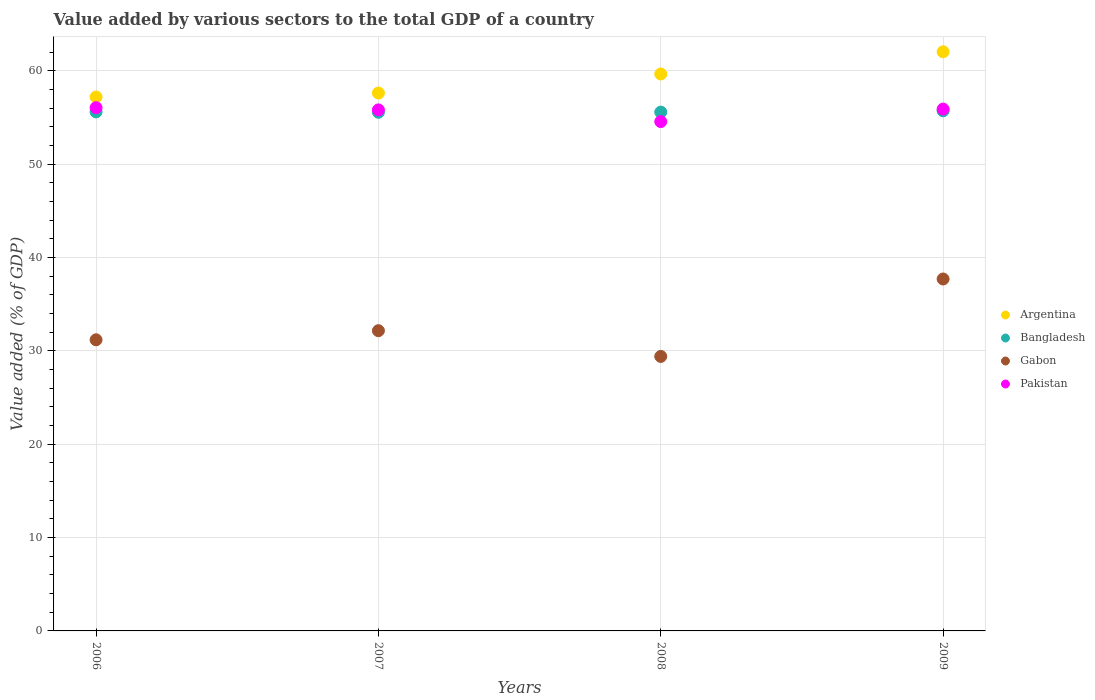Is the number of dotlines equal to the number of legend labels?
Offer a terse response. Yes. What is the value added by various sectors to the total GDP in Pakistan in 2009?
Ensure brevity in your answer.  55.89. Across all years, what is the maximum value added by various sectors to the total GDP in Argentina?
Offer a terse response. 62.03. Across all years, what is the minimum value added by various sectors to the total GDP in Pakistan?
Your answer should be compact. 54.56. In which year was the value added by various sectors to the total GDP in Argentina maximum?
Offer a terse response. 2009. What is the total value added by various sectors to the total GDP in Gabon in the graph?
Offer a very short reply. 130.44. What is the difference between the value added by various sectors to the total GDP in Bangladesh in 2006 and that in 2008?
Keep it short and to the point. 0.03. What is the difference between the value added by various sectors to the total GDP in Gabon in 2006 and the value added by various sectors to the total GDP in Pakistan in 2007?
Offer a terse response. -24.63. What is the average value added by various sectors to the total GDP in Bangladesh per year?
Keep it short and to the point. 55.61. In the year 2009, what is the difference between the value added by various sectors to the total GDP in Bangladesh and value added by various sectors to the total GDP in Argentina?
Offer a terse response. -6.32. What is the ratio of the value added by various sectors to the total GDP in Bangladesh in 2008 to that in 2009?
Make the answer very short. 1. Is the value added by various sectors to the total GDP in Argentina in 2007 less than that in 2009?
Ensure brevity in your answer.  Yes. What is the difference between the highest and the second highest value added by various sectors to the total GDP in Argentina?
Keep it short and to the point. 2.38. What is the difference between the highest and the lowest value added by various sectors to the total GDP in Gabon?
Provide a short and direct response. 8.29. Is the sum of the value added by various sectors to the total GDP in Bangladesh in 2007 and 2009 greater than the maximum value added by various sectors to the total GDP in Argentina across all years?
Keep it short and to the point. Yes. Is the value added by various sectors to the total GDP in Bangladesh strictly greater than the value added by various sectors to the total GDP in Pakistan over the years?
Your answer should be compact. No. How many dotlines are there?
Your answer should be compact. 4. Does the graph contain any zero values?
Offer a terse response. No. Where does the legend appear in the graph?
Ensure brevity in your answer.  Center right. How many legend labels are there?
Provide a succinct answer. 4. What is the title of the graph?
Provide a short and direct response. Value added by various sectors to the total GDP of a country. Does "Brunei Darussalam" appear as one of the legend labels in the graph?
Your response must be concise. No. What is the label or title of the Y-axis?
Make the answer very short. Value added (% of GDP). What is the Value added (% of GDP) of Argentina in 2006?
Offer a very short reply. 57.19. What is the Value added (% of GDP) of Bangladesh in 2006?
Your answer should be compact. 55.59. What is the Value added (% of GDP) of Gabon in 2006?
Offer a very short reply. 31.18. What is the Value added (% of GDP) of Pakistan in 2006?
Your answer should be very brief. 56.04. What is the Value added (% of GDP) in Argentina in 2007?
Your response must be concise. 57.61. What is the Value added (% of GDP) in Bangladesh in 2007?
Offer a terse response. 55.56. What is the Value added (% of GDP) of Gabon in 2007?
Offer a terse response. 32.16. What is the Value added (% of GDP) in Pakistan in 2007?
Offer a very short reply. 55.81. What is the Value added (% of GDP) in Argentina in 2008?
Your answer should be very brief. 59.65. What is the Value added (% of GDP) in Bangladesh in 2008?
Make the answer very short. 55.57. What is the Value added (% of GDP) of Gabon in 2008?
Ensure brevity in your answer.  29.4. What is the Value added (% of GDP) in Pakistan in 2008?
Give a very brief answer. 54.56. What is the Value added (% of GDP) of Argentina in 2009?
Give a very brief answer. 62.03. What is the Value added (% of GDP) in Bangladesh in 2009?
Offer a terse response. 55.71. What is the Value added (% of GDP) of Gabon in 2009?
Give a very brief answer. 37.7. What is the Value added (% of GDP) of Pakistan in 2009?
Keep it short and to the point. 55.89. Across all years, what is the maximum Value added (% of GDP) in Argentina?
Offer a very short reply. 62.03. Across all years, what is the maximum Value added (% of GDP) of Bangladesh?
Offer a very short reply. 55.71. Across all years, what is the maximum Value added (% of GDP) in Gabon?
Ensure brevity in your answer.  37.7. Across all years, what is the maximum Value added (% of GDP) of Pakistan?
Provide a succinct answer. 56.04. Across all years, what is the minimum Value added (% of GDP) of Argentina?
Make the answer very short. 57.19. Across all years, what is the minimum Value added (% of GDP) of Bangladesh?
Give a very brief answer. 55.56. Across all years, what is the minimum Value added (% of GDP) of Gabon?
Offer a terse response. 29.4. Across all years, what is the minimum Value added (% of GDP) of Pakistan?
Keep it short and to the point. 54.56. What is the total Value added (% of GDP) of Argentina in the graph?
Provide a short and direct response. 236.49. What is the total Value added (% of GDP) of Bangladesh in the graph?
Provide a short and direct response. 222.42. What is the total Value added (% of GDP) in Gabon in the graph?
Ensure brevity in your answer.  130.44. What is the total Value added (% of GDP) in Pakistan in the graph?
Your response must be concise. 222.3. What is the difference between the Value added (% of GDP) of Argentina in 2006 and that in 2007?
Ensure brevity in your answer.  -0.42. What is the difference between the Value added (% of GDP) in Bangladesh in 2006 and that in 2007?
Your answer should be compact. 0.04. What is the difference between the Value added (% of GDP) in Gabon in 2006 and that in 2007?
Provide a short and direct response. -0.98. What is the difference between the Value added (% of GDP) of Pakistan in 2006 and that in 2007?
Make the answer very short. 0.24. What is the difference between the Value added (% of GDP) of Argentina in 2006 and that in 2008?
Give a very brief answer. -2.46. What is the difference between the Value added (% of GDP) in Bangladesh in 2006 and that in 2008?
Offer a terse response. 0.03. What is the difference between the Value added (% of GDP) in Gabon in 2006 and that in 2008?
Keep it short and to the point. 1.78. What is the difference between the Value added (% of GDP) in Pakistan in 2006 and that in 2008?
Offer a terse response. 1.49. What is the difference between the Value added (% of GDP) of Argentina in 2006 and that in 2009?
Provide a succinct answer. -4.84. What is the difference between the Value added (% of GDP) of Bangladesh in 2006 and that in 2009?
Provide a short and direct response. -0.11. What is the difference between the Value added (% of GDP) of Gabon in 2006 and that in 2009?
Your response must be concise. -6.51. What is the difference between the Value added (% of GDP) of Pakistan in 2006 and that in 2009?
Your answer should be compact. 0.15. What is the difference between the Value added (% of GDP) of Argentina in 2007 and that in 2008?
Your answer should be very brief. -2.04. What is the difference between the Value added (% of GDP) in Bangladesh in 2007 and that in 2008?
Provide a short and direct response. -0.01. What is the difference between the Value added (% of GDP) in Gabon in 2007 and that in 2008?
Give a very brief answer. 2.76. What is the difference between the Value added (% of GDP) of Pakistan in 2007 and that in 2008?
Provide a succinct answer. 1.25. What is the difference between the Value added (% of GDP) in Argentina in 2007 and that in 2009?
Your answer should be compact. -4.42. What is the difference between the Value added (% of GDP) in Bangladesh in 2007 and that in 2009?
Keep it short and to the point. -0.15. What is the difference between the Value added (% of GDP) in Gabon in 2007 and that in 2009?
Offer a terse response. -5.54. What is the difference between the Value added (% of GDP) of Pakistan in 2007 and that in 2009?
Provide a short and direct response. -0.09. What is the difference between the Value added (% of GDP) in Argentina in 2008 and that in 2009?
Offer a terse response. -2.38. What is the difference between the Value added (% of GDP) of Bangladesh in 2008 and that in 2009?
Offer a very short reply. -0.14. What is the difference between the Value added (% of GDP) in Gabon in 2008 and that in 2009?
Your answer should be very brief. -8.29. What is the difference between the Value added (% of GDP) in Pakistan in 2008 and that in 2009?
Provide a short and direct response. -1.34. What is the difference between the Value added (% of GDP) of Argentina in 2006 and the Value added (% of GDP) of Bangladesh in 2007?
Keep it short and to the point. 1.64. What is the difference between the Value added (% of GDP) in Argentina in 2006 and the Value added (% of GDP) in Gabon in 2007?
Make the answer very short. 25.03. What is the difference between the Value added (% of GDP) of Argentina in 2006 and the Value added (% of GDP) of Pakistan in 2007?
Provide a succinct answer. 1.38. What is the difference between the Value added (% of GDP) in Bangladesh in 2006 and the Value added (% of GDP) in Gabon in 2007?
Provide a succinct answer. 23.44. What is the difference between the Value added (% of GDP) in Bangladesh in 2006 and the Value added (% of GDP) in Pakistan in 2007?
Make the answer very short. -0.21. What is the difference between the Value added (% of GDP) in Gabon in 2006 and the Value added (% of GDP) in Pakistan in 2007?
Your answer should be very brief. -24.63. What is the difference between the Value added (% of GDP) of Argentina in 2006 and the Value added (% of GDP) of Bangladesh in 2008?
Offer a terse response. 1.62. What is the difference between the Value added (% of GDP) of Argentina in 2006 and the Value added (% of GDP) of Gabon in 2008?
Offer a terse response. 27.79. What is the difference between the Value added (% of GDP) of Argentina in 2006 and the Value added (% of GDP) of Pakistan in 2008?
Make the answer very short. 2.64. What is the difference between the Value added (% of GDP) in Bangladesh in 2006 and the Value added (% of GDP) in Gabon in 2008?
Provide a short and direct response. 26.19. What is the difference between the Value added (% of GDP) of Bangladesh in 2006 and the Value added (% of GDP) of Pakistan in 2008?
Provide a short and direct response. 1.04. What is the difference between the Value added (% of GDP) of Gabon in 2006 and the Value added (% of GDP) of Pakistan in 2008?
Offer a terse response. -23.37. What is the difference between the Value added (% of GDP) of Argentina in 2006 and the Value added (% of GDP) of Bangladesh in 2009?
Your response must be concise. 1.49. What is the difference between the Value added (% of GDP) of Argentina in 2006 and the Value added (% of GDP) of Gabon in 2009?
Give a very brief answer. 19.49. What is the difference between the Value added (% of GDP) in Argentina in 2006 and the Value added (% of GDP) in Pakistan in 2009?
Give a very brief answer. 1.3. What is the difference between the Value added (% of GDP) in Bangladesh in 2006 and the Value added (% of GDP) in Gabon in 2009?
Offer a very short reply. 17.9. What is the difference between the Value added (% of GDP) in Bangladesh in 2006 and the Value added (% of GDP) in Pakistan in 2009?
Your answer should be very brief. -0.3. What is the difference between the Value added (% of GDP) in Gabon in 2006 and the Value added (% of GDP) in Pakistan in 2009?
Provide a short and direct response. -24.71. What is the difference between the Value added (% of GDP) of Argentina in 2007 and the Value added (% of GDP) of Bangladesh in 2008?
Your response must be concise. 2.04. What is the difference between the Value added (% of GDP) in Argentina in 2007 and the Value added (% of GDP) in Gabon in 2008?
Your answer should be very brief. 28.21. What is the difference between the Value added (% of GDP) of Argentina in 2007 and the Value added (% of GDP) of Pakistan in 2008?
Offer a very short reply. 3.06. What is the difference between the Value added (% of GDP) in Bangladesh in 2007 and the Value added (% of GDP) in Gabon in 2008?
Your response must be concise. 26.15. What is the difference between the Value added (% of GDP) in Bangladesh in 2007 and the Value added (% of GDP) in Pakistan in 2008?
Your answer should be very brief. 1. What is the difference between the Value added (% of GDP) in Gabon in 2007 and the Value added (% of GDP) in Pakistan in 2008?
Give a very brief answer. -22.4. What is the difference between the Value added (% of GDP) of Argentina in 2007 and the Value added (% of GDP) of Bangladesh in 2009?
Provide a succinct answer. 1.91. What is the difference between the Value added (% of GDP) in Argentina in 2007 and the Value added (% of GDP) in Gabon in 2009?
Keep it short and to the point. 19.92. What is the difference between the Value added (% of GDP) of Argentina in 2007 and the Value added (% of GDP) of Pakistan in 2009?
Your answer should be compact. 1.72. What is the difference between the Value added (% of GDP) of Bangladesh in 2007 and the Value added (% of GDP) of Gabon in 2009?
Your answer should be very brief. 17.86. What is the difference between the Value added (% of GDP) in Bangladesh in 2007 and the Value added (% of GDP) in Pakistan in 2009?
Make the answer very short. -0.34. What is the difference between the Value added (% of GDP) in Gabon in 2007 and the Value added (% of GDP) in Pakistan in 2009?
Ensure brevity in your answer.  -23.74. What is the difference between the Value added (% of GDP) in Argentina in 2008 and the Value added (% of GDP) in Bangladesh in 2009?
Offer a terse response. 3.95. What is the difference between the Value added (% of GDP) in Argentina in 2008 and the Value added (% of GDP) in Gabon in 2009?
Keep it short and to the point. 21.96. What is the difference between the Value added (% of GDP) in Argentina in 2008 and the Value added (% of GDP) in Pakistan in 2009?
Provide a short and direct response. 3.76. What is the difference between the Value added (% of GDP) in Bangladesh in 2008 and the Value added (% of GDP) in Gabon in 2009?
Your answer should be very brief. 17.87. What is the difference between the Value added (% of GDP) of Bangladesh in 2008 and the Value added (% of GDP) of Pakistan in 2009?
Ensure brevity in your answer.  -0.33. What is the difference between the Value added (% of GDP) of Gabon in 2008 and the Value added (% of GDP) of Pakistan in 2009?
Your answer should be very brief. -26.49. What is the average Value added (% of GDP) in Argentina per year?
Make the answer very short. 59.12. What is the average Value added (% of GDP) in Bangladesh per year?
Ensure brevity in your answer.  55.61. What is the average Value added (% of GDP) in Gabon per year?
Your answer should be compact. 32.61. What is the average Value added (% of GDP) of Pakistan per year?
Your answer should be very brief. 55.58. In the year 2006, what is the difference between the Value added (% of GDP) in Argentina and Value added (% of GDP) in Bangladesh?
Offer a very short reply. 1.6. In the year 2006, what is the difference between the Value added (% of GDP) in Argentina and Value added (% of GDP) in Gabon?
Provide a short and direct response. 26.01. In the year 2006, what is the difference between the Value added (% of GDP) of Argentina and Value added (% of GDP) of Pakistan?
Make the answer very short. 1.15. In the year 2006, what is the difference between the Value added (% of GDP) of Bangladesh and Value added (% of GDP) of Gabon?
Provide a short and direct response. 24.41. In the year 2006, what is the difference between the Value added (% of GDP) of Bangladesh and Value added (% of GDP) of Pakistan?
Make the answer very short. -0.45. In the year 2006, what is the difference between the Value added (% of GDP) of Gabon and Value added (% of GDP) of Pakistan?
Keep it short and to the point. -24.86. In the year 2007, what is the difference between the Value added (% of GDP) in Argentina and Value added (% of GDP) in Bangladesh?
Give a very brief answer. 2.06. In the year 2007, what is the difference between the Value added (% of GDP) in Argentina and Value added (% of GDP) in Gabon?
Your response must be concise. 25.46. In the year 2007, what is the difference between the Value added (% of GDP) of Argentina and Value added (% of GDP) of Pakistan?
Your response must be concise. 1.81. In the year 2007, what is the difference between the Value added (% of GDP) in Bangladesh and Value added (% of GDP) in Gabon?
Your response must be concise. 23.4. In the year 2007, what is the difference between the Value added (% of GDP) in Bangladesh and Value added (% of GDP) in Pakistan?
Keep it short and to the point. -0.25. In the year 2007, what is the difference between the Value added (% of GDP) in Gabon and Value added (% of GDP) in Pakistan?
Your answer should be very brief. -23.65. In the year 2008, what is the difference between the Value added (% of GDP) in Argentina and Value added (% of GDP) in Bangladesh?
Keep it short and to the point. 4.08. In the year 2008, what is the difference between the Value added (% of GDP) of Argentina and Value added (% of GDP) of Gabon?
Provide a succinct answer. 30.25. In the year 2008, what is the difference between the Value added (% of GDP) in Argentina and Value added (% of GDP) in Pakistan?
Make the answer very short. 5.1. In the year 2008, what is the difference between the Value added (% of GDP) of Bangladesh and Value added (% of GDP) of Gabon?
Your answer should be compact. 26.17. In the year 2008, what is the difference between the Value added (% of GDP) of Bangladesh and Value added (% of GDP) of Pakistan?
Provide a short and direct response. 1.01. In the year 2008, what is the difference between the Value added (% of GDP) in Gabon and Value added (% of GDP) in Pakistan?
Provide a short and direct response. -25.15. In the year 2009, what is the difference between the Value added (% of GDP) of Argentina and Value added (% of GDP) of Bangladesh?
Ensure brevity in your answer.  6.32. In the year 2009, what is the difference between the Value added (% of GDP) in Argentina and Value added (% of GDP) in Gabon?
Provide a succinct answer. 24.33. In the year 2009, what is the difference between the Value added (% of GDP) of Argentina and Value added (% of GDP) of Pakistan?
Your response must be concise. 6.14. In the year 2009, what is the difference between the Value added (% of GDP) of Bangladesh and Value added (% of GDP) of Gabon?
Give a very brief answer. 18.01. In the year 2009, what is the difference between the Value added (% of GDP) in Bangladesh and Value added (% of GDP) in Pakistan?
Provide a succinct answer. -0.19. In the year 2009, what is the difference between the Value added (% of GDP) of Gabon and Value added (% of GDP) of Pakistan?
Your answer should be compact. -18.2. What is the ratio of the Value added (% of GDP) of Bangladesh in 2006 to that in 2007?
Provide a short and direct response. 1. What is the ratio of the Value added (% of GDP) in Gabon in 2006 to that in 2007?
Your answer should be compact. 0.97. What is the ratio of the Value added (% of GDP) of Argentina in 2006 to that in 2008?
Provide a succinct answer. 0.96. What is the ratio of the Value added (% of GDP) of Bangladesh in 2006 to that in 2008?
Provide a succinct answer. 1. What is the ratio of the Value added (% of GDP) in Gabon in 2006 to that in 2008?
Ensure brevity in your answer.  1.06. What is the ratio of the Value added (% of GDP) in Pakistan in 2006 to that in 2008?
Ensure brevity in your answer.  1.03. What is the ratio of the Value added (% of GDP) in Argentina in 2006 to that in 2009?
Provide a succinct answer. 0.92. What is the ratio of the Value added (% of GDP) in Gabon in 2006 to that in 2009?
Make the answer very short. 0.83. What is the ratio of the Value added (% of GDP) in Pakistan in 2006 to that in 2009?
Make the answer very short. 1. What is the ratio of the Value added (% of GDP) in Argentina in 2007 to that in 2008?
Provide a succinct answer. 0.97. What is the ratio of the Value added (% of GDP) in Gabon in 2007 to that in 2008?
Your answer should be compact. 1.09. What is the ratio of the Value added (% of GDP) of Pakistan in 2007 to that in 2008?
Ensure brevity in your answer.  1.02. What is the ratio of the Value added (% of GDP) in Argentina in 2007 to that in 2009?
Ensure brevity in your answer.  0.93. What is the ratio of the Value added (% of GDP) of Bangladesh in 2007 to that in 2009?
Provide a succinct answer. 1. What is the ratio of the Value added (% of GDP) of Gabon in 2007 to that in 2009?
Your answer should be very brief. 0.85. What is the ratio of the Value added (% of GDP) of Argentina in 2008 to that in 2009?
Give a very brief answer. 0.96. What is the ratio of the Value added (% of GDP) in Bangladesh in 2008 to that in 2009?
Provide a succinct answer. 1. What is the ratio of the Value added (% of GDP) in Gabon in 2008 to that in 2009?
Your answer should be very brief. 0.78. What is the ratio of the Value added (% of GDP) of Pakistan in 2008 to that in 2009?
Offer a very short reply. 0.98. What is the difference between the highest and the second highest Value added (% of GDP) in Argentina?
Make the answer very short. 2.38. What is the difference between the highest and the second highest Value added (% of GDP) in Bangladesh?
Provide a succinct answer. 0.11. What is the difference between the highest and the second highest Value added (% of GDP) in Gabon?
Provide a short and direct response. 5.54. What is the difference between the highest and the second highest Value added (% of GDP) in Pakistan?
Provide a short and direct response. 0.15. What is the difference between the highest and the lowest Value added (% of GDP) of Argentina?
Keep it short and to the point. 4.84. What is the difference between the highest and the lowest Value added (% of GDP) of Bangladesh?
Your response must be concise. 0.15. What is the difference between the highest and the lowest Value added (% of GDP) of Gabon?
Your answer should be compact. 8.29. What is the difference between the highest and the lowest Value added (% of GDP) of Pakistan?
Your answer should be very brief. 1.49. 